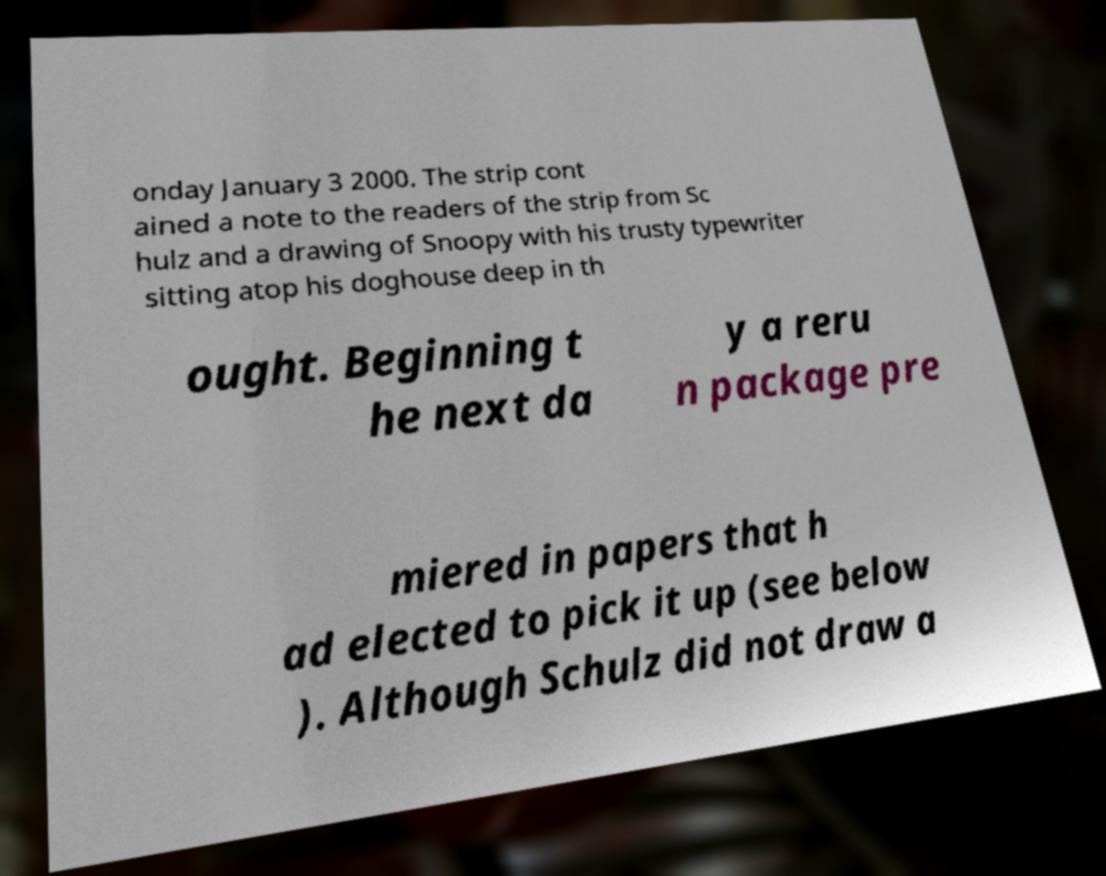Can you read and provide the text displayed in the image?This photo seems to have some interesting text. Can you extract and type it out for me? onday January 3 2000. The strip cont ained a note to the readers of the strip from Sc hulz and a drawing of Snoopy with his trusty typewriter sitting atop his doghouse deep in th ought. Beginning t he next da y a reru n package pre miered in papers that h ad elected to pick it up (see below ). Although Schulz did not draw a 